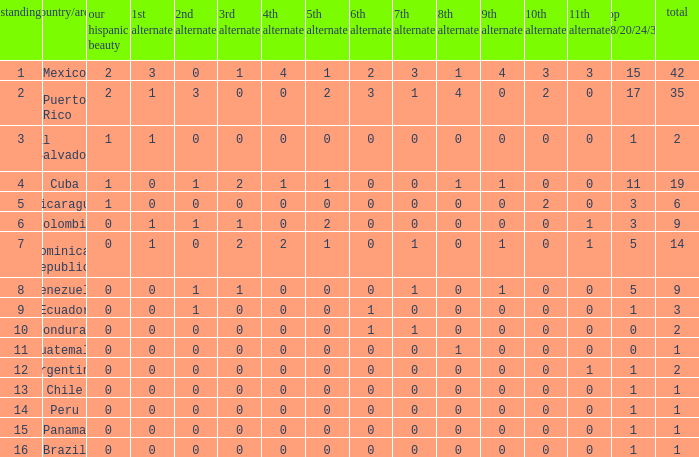What is the 7th runner-up of the country with a 10th runner-up greater than 0, a 9th runner-up greater than 0, and an 8th runner-up greater than 1? None. 